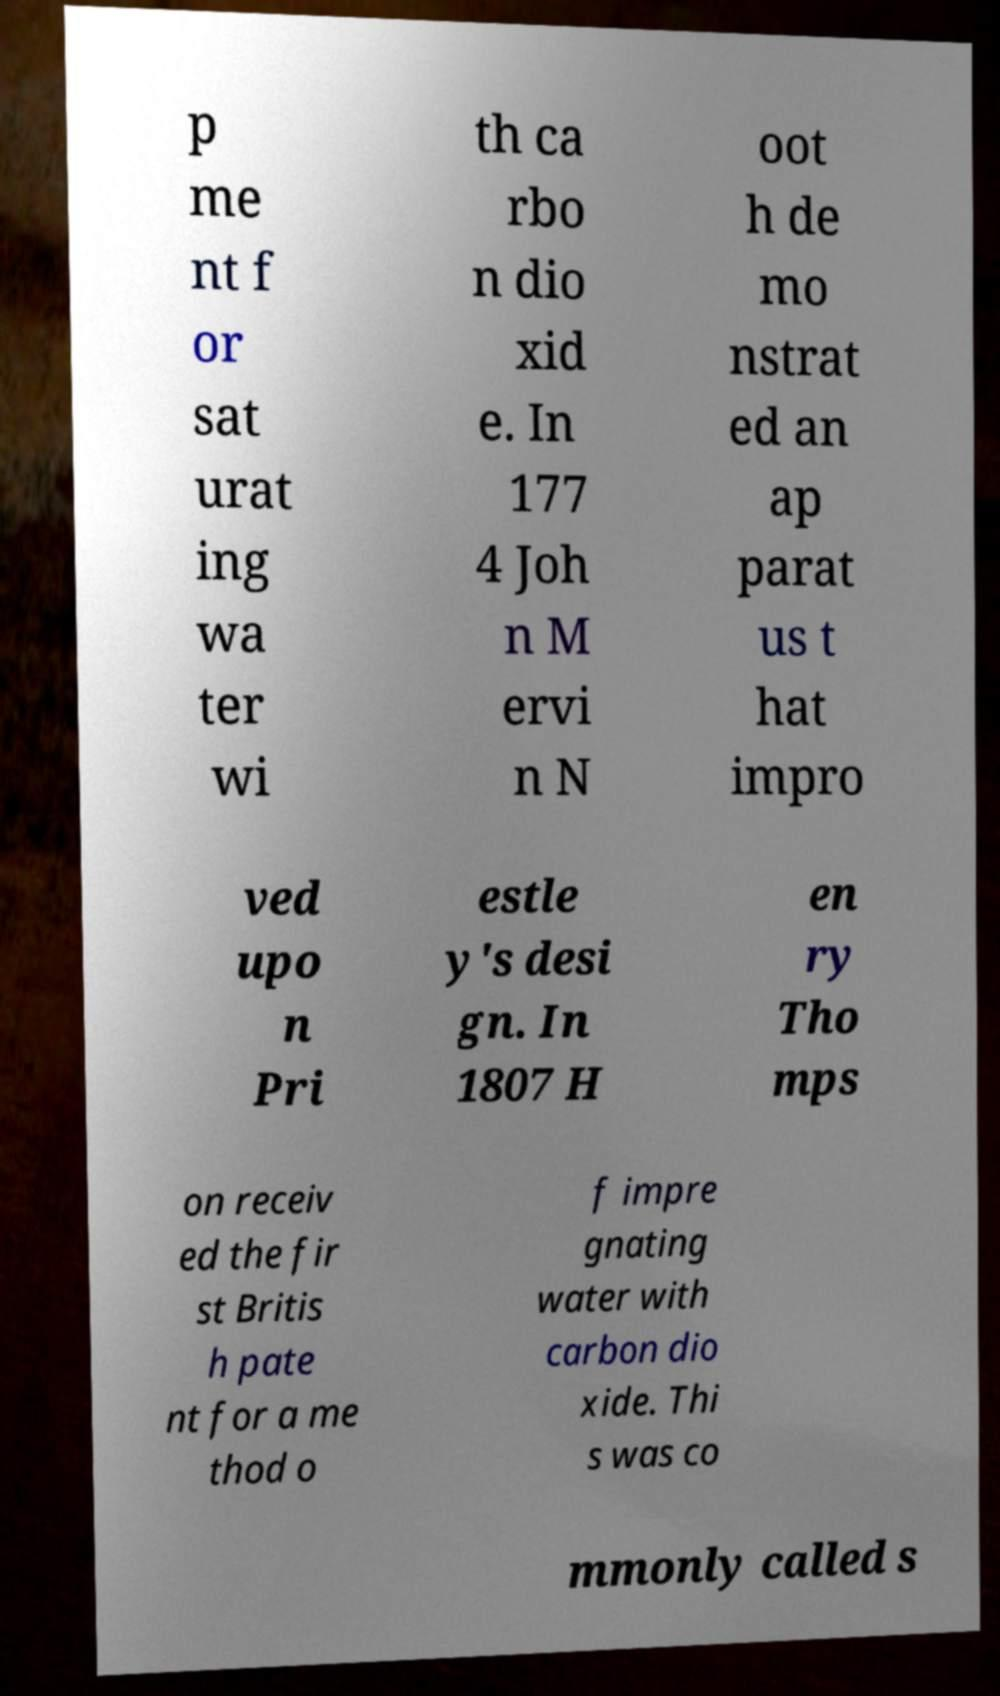Could you extract and type out the text from this image? p me nt f or sat urat ing wa ter wi th ca rbo n dio xid e. In 177 4 Joh n M ervi n N oot h de mo nstrat ed an ap parat us t hat impro ved upo n Pri estle y's desi gn. In 1807 H en ry Tho mps on receiv ed the fir st Britis h pate nt for a me thod o f impre gnating water with carbon dio xide. Thi s was co mmonly called s 